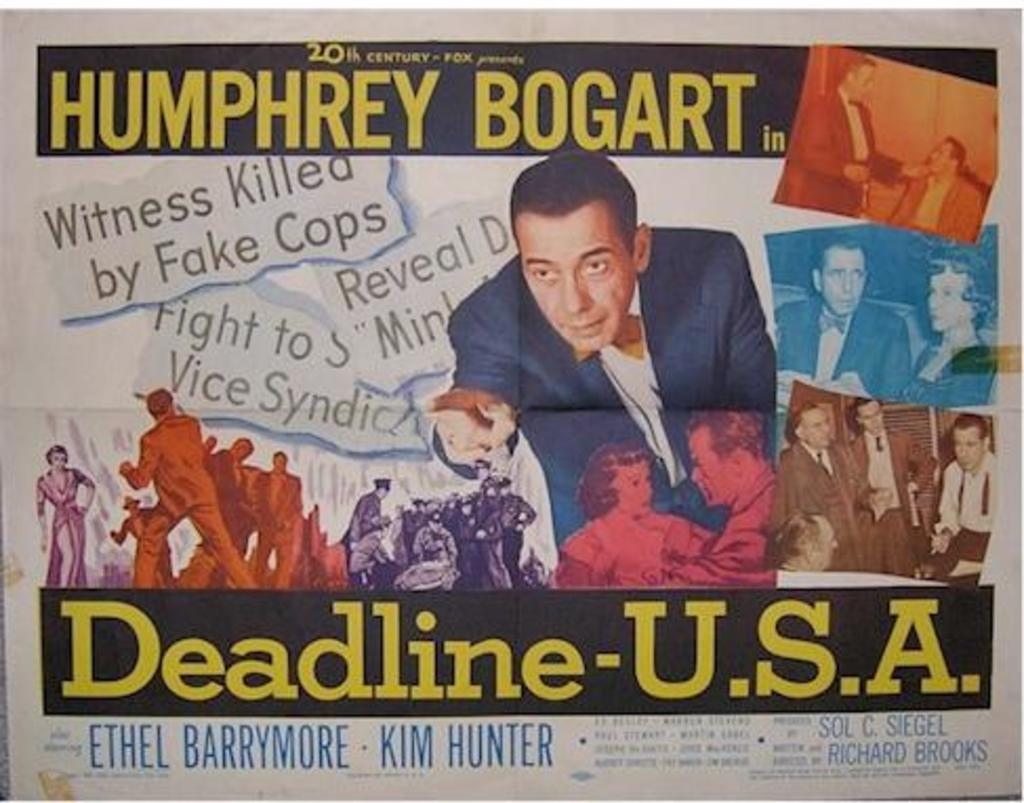<image>
Offer a succinct explanation of the picture presented. A Humphrey Bogart movie is called Deadline- USA. 